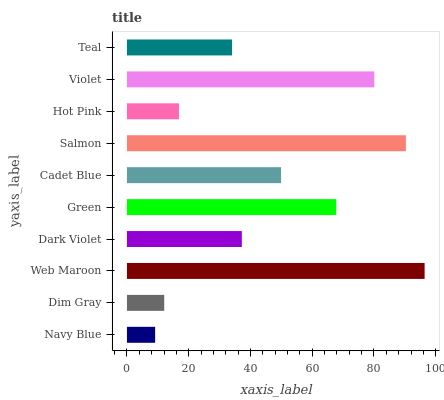Is Navy Blue the minimum?
Answer yes or no. Yes. Is Web Maroon the maximum?
Answer yes or no. Yes. Is Dim Gray the minimum?
Answer yes or no. No. Is Dim Gray the maximum?
Answer yes or no. No. Is Dim Gray greater than Navy Blue?
Answer yes or no. Yes. Is Navy Blue less than Dim Gray?
Answer yes or no. Yes. Is Navy Blue greater than Dim Gray?
Answer yes or no. No. Is Dim Gray less than Navy Blue?
Answer yes or no. No. Is Cadet Blue the high median?
Answer yes or no. Yes. Is Dark Violet the low median?
Answer yes or no. Yes. Is Hot Pink the high median?
Answer yes or no. No. Is Salmon the low median?
Answer yes or no. No. 